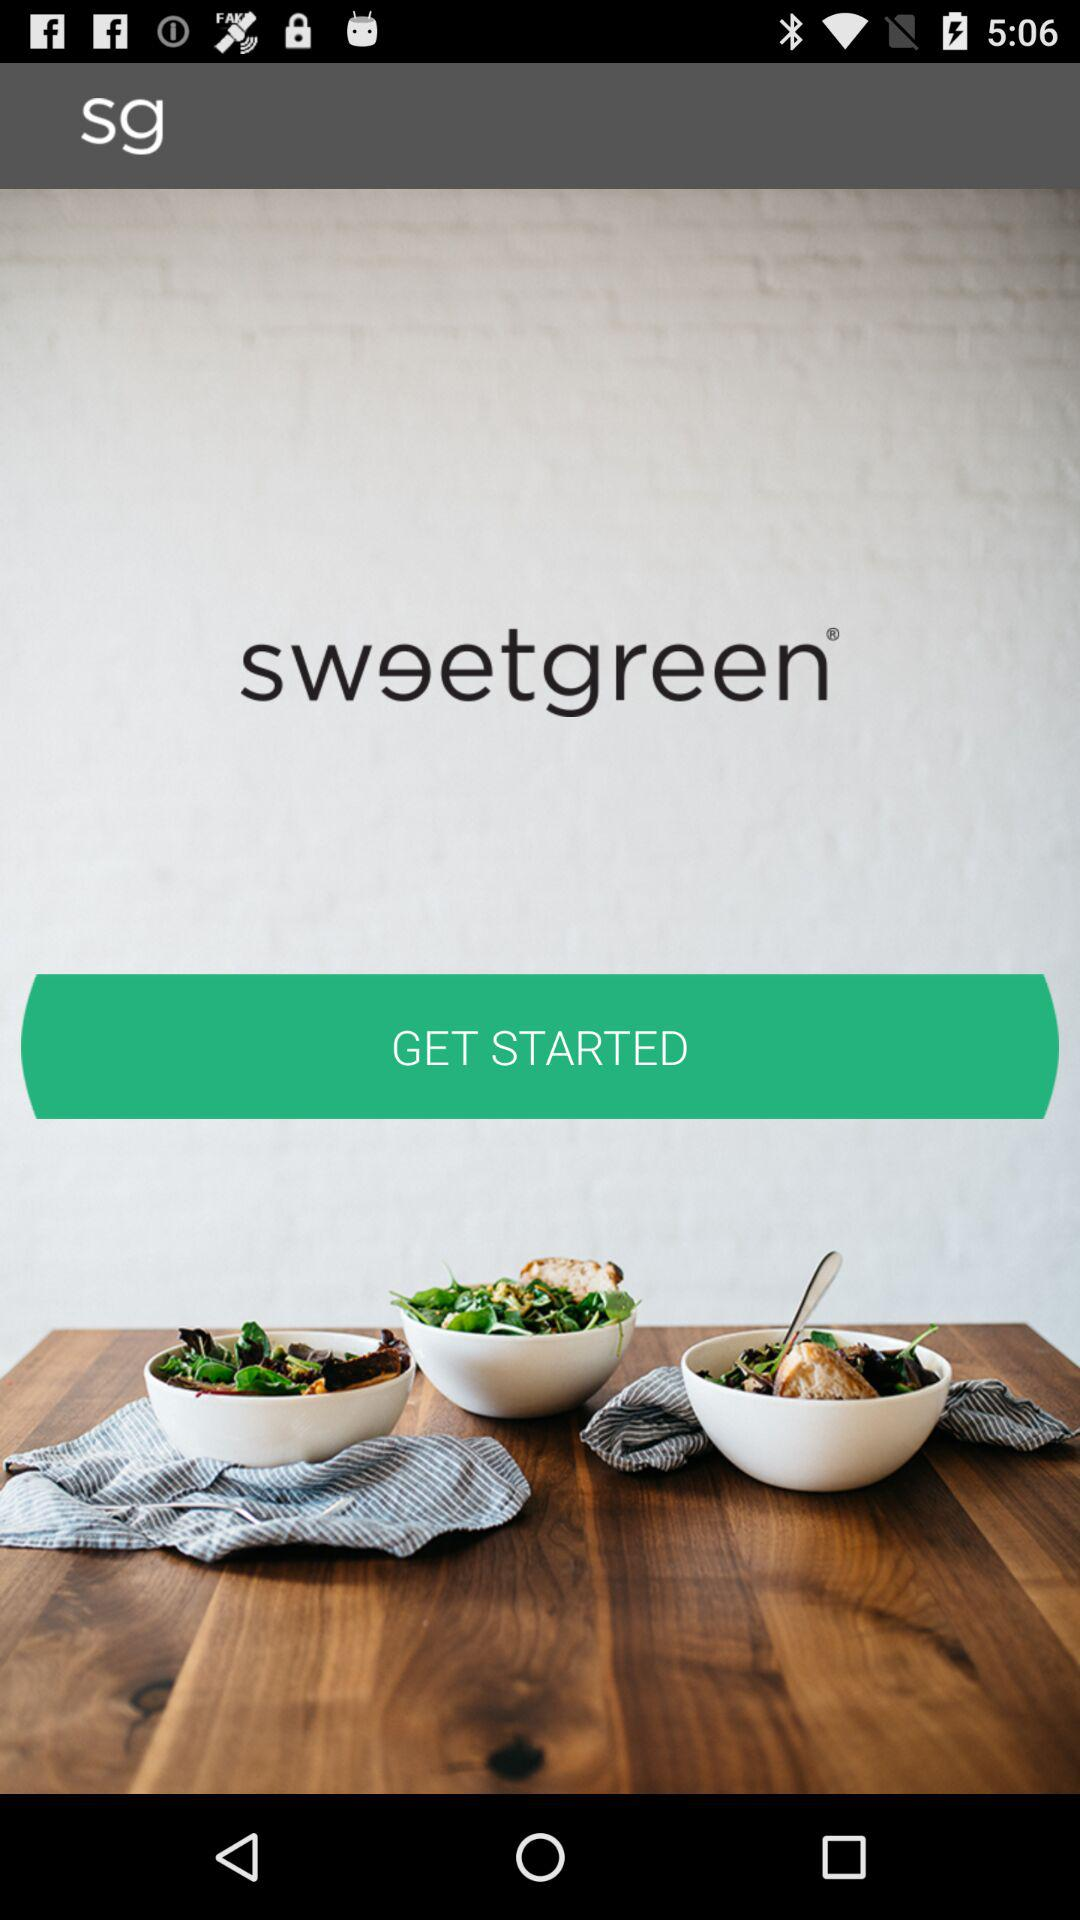What is the name of the application? The name of the application is "sweetgreen". 